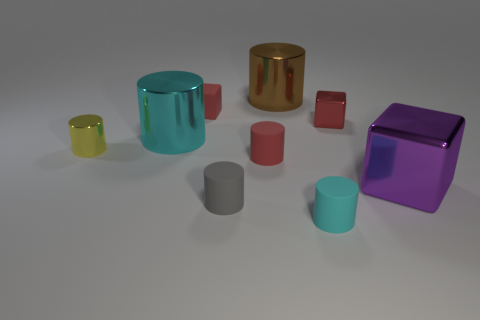What size is the shiny block that is the same color as the matte block?
Your answer should be compact. Small. Is the color of the small shiny cube the same as the small metallic cylinder?
Provide a short and direct response. No. Does the cyan thing behind the purple cube have the same shape as the yellow metallic object?
Make the answer very short. Yes. What number of gray objects have the same size as the purple metal cube?
Provide a short and direct response. 0. There is a tiny metallic thing that is the same color as the rubber block; what is its shape?
Offer a terse response. Cube. There is a large shiny block that is in front of the brown metal object; is there a red cylinder that is in front of it?
Ensure brevity in your answer.  No. What number of things are big objects that are behind the tiny yellow object or small cyan rubber things?
Ensure brevity in your answer.  3. How many big gray objects are there?
Offer a terse response. 0. The small red thing that is made of the same material as the purple thing is what shape?
Ensure brevity in your answer.  Cube. What is the size of the cyan object that is behind the big thing that is in front of the small yellow cylinder?
Provide a succinct answer. Large. 